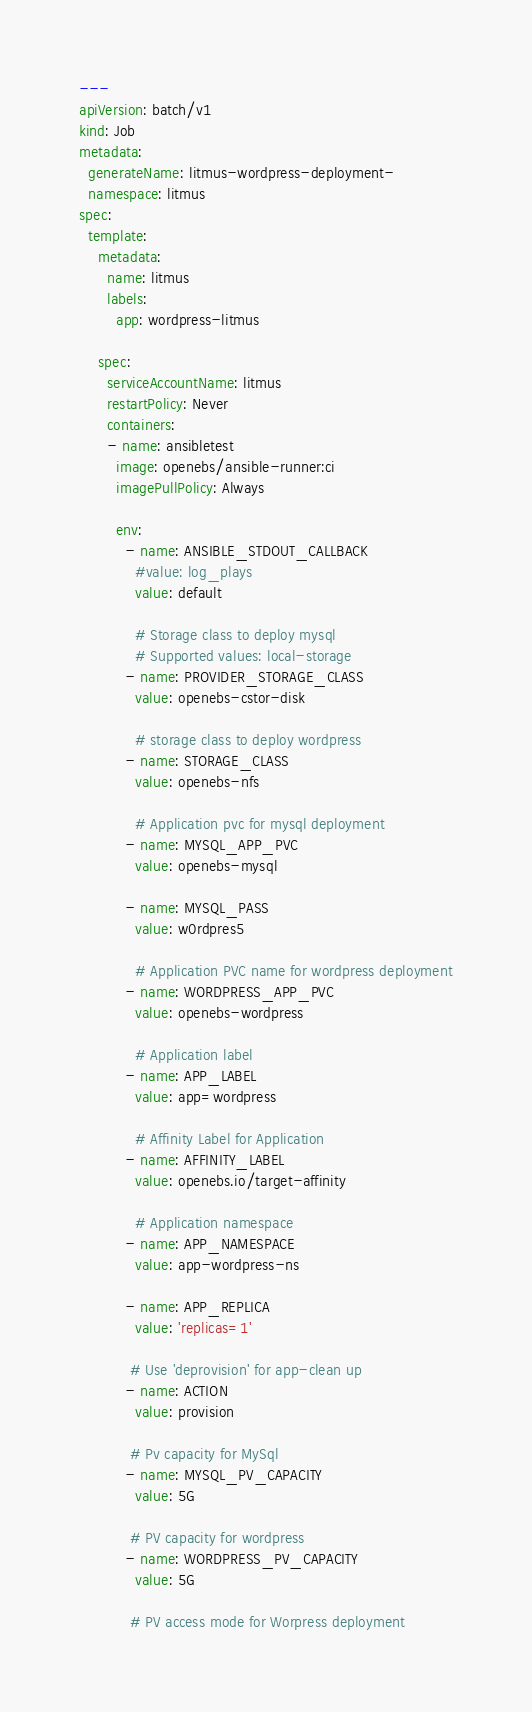<code> <loc_0><loc_0><loc_500><loc_500><_YAML_>---
apiVersion: batch/v1
kind: Job
metadata:
  generateName: litmus-wordpress-deployment-
  namespace: litmus
spec:
  template:
    metadata:
      name: litmus
      labels:
        app: wordpress-litmus

    spec:
      serviceAccountName: litmus
      restartPolicy: Never
      containers:
      - name: ansibletest
        image: openebs/ansible-runner:ci
        imagePullPolicy: Always

        env:
          - name: ANSIBLE_STDOUT_CALLBACK
            #value: log_plays
            value: default

            # Storage class to deploy mysql
            # Supported values: local-storage
          - name: PROVIDER_STORAGE_CLASS
            value: openebs-cstor-disk

            # storage class to deploy wordpress
          - name: STORAGE_CLASS
            value: openebs-nfs

            # Application pvc for mysql deployment
          - name: MYSQL_APP_PVC
            value: openebs-mysql

          - name: MYSQL_PASS
            value: w0rdpres5

            # Application PVC name for wordpress deployment
          - name: WORDPRESS_APP_PVC
            value: openebs-wordpress

            # Application label
          - name: APP_LABEL
            value: app=wordpress

            # Affinity Label for Application
          - name: AFFINITY_LABEL
            value: openebs.io/target-affinity

            # Application namespace
          - name: APP_NAMESPACE
            value: app-wordpress-ns 

          - name: APP_REPLICA
            value: 'replicas=1'
            
           # Use 'deprovision' for app-clean up
          - name: ACTION
            value: provision

           # Pv capacity for MySql
          - name: MYSQL_PV_CAPACITY
            value: 5G

           # PV capacity for wordpress  
          - name: WORDPRESS_PV_CAPACITY
            value: 5G

           # PV access mode for Worpress deployment</code> 